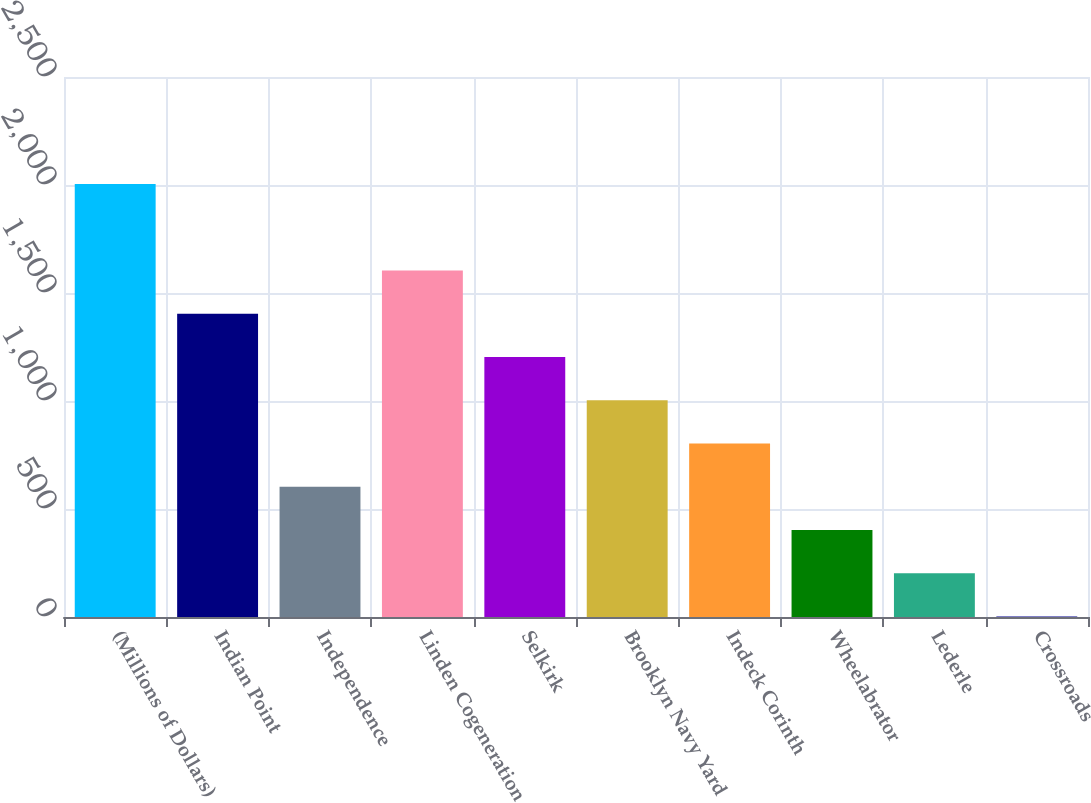Convert chart to OTSL. <chart><loc_0><loc_0><loc_500><loc_500><bar_chart><fcel>(Millions of Dollars)<fcel>Indian Point<fcel>Independence<fcel>Linden Cogeneration<fcel>Selkirk<fcel>Brooklyn Navy Yard<fcel>Indeck Corinth<fcel>Wheelabrator<fcel>Lederle<fcel>Crossroads<nl><fcel>2005<fcel>1404.1<fcel>602.9<fcel>1604.4<fcel>1203.8<fcel>1003.5<fcel>803.2<fcel>402.6<fcel>202.3<fcel>2<nl></chart> 